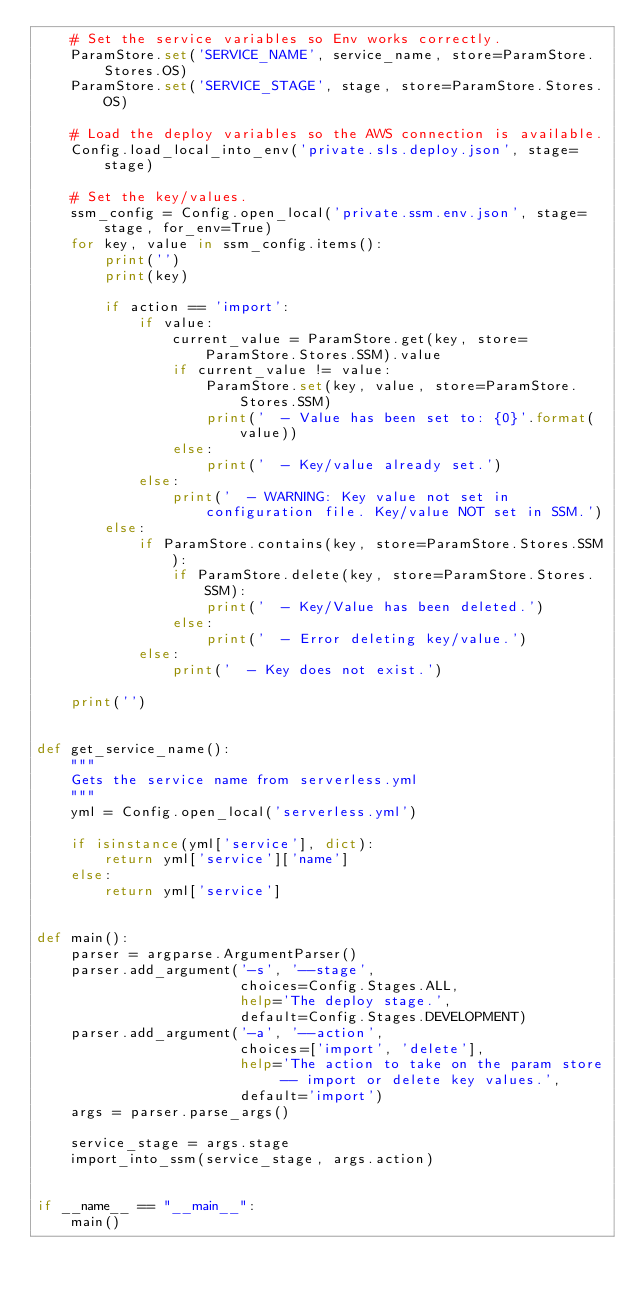<code> <loc_0><loc_0><loc_500><loc_500><_Python_>    # Set the service variables so Env works correctly.
    ParamStore.set('SERVICE_NAME', service_name, store=ParamStore.Stores.OS)
    ParamStore.set('SERVICE_STAGE', stage, store=ParamStore.Stores.OS)

    # Load the deploy variables so the AWS connection is available.
    Config.load_local_into_env('private.sls.deploy.json', stage=stage)

    # Set the key/values.
    ssm_config = Config.open_local('private.ssm.env.json', stage=stage, for_env=True)
    for key, value in ssm_config.items():
        print('')
        print(key)

        if action == 'import':
            if value:
                current_value = ParamStore.get(key, store=ParamStore.Stores.SSM).value
                if current_value != value:
                    ParamStore.set(key, value, store=ParamStore.Stores.SSM)
                    print('  - Value has been set to: {0}'.format(value))
                else:
                    print('  - Key/value already set.')
            else:
                print('  - WARNING: Key value not set in configuration file. Key/value NOT set in SSM.')
        else:
            if ParamStore.contains(key, store=ParamStore.Stores.SSM):
                if ParamStore.delete(key, store=ParamStore.Stores.SSM):
                    print('  - Key/Value has been deleted.')
                else:
                    print('  - Error deleting key/value.')
            else:
                print('  - Key does not exist.')

    print('')


def get_service_name():
    """
    Gets the service name from serverless.yml
    """
    yml = Config.open_local('serverless.yml')

    if isinstance(yml['service'], dict):
        return yml['service']['name']
    else:
        return yml['service']


def main():
    parser = argparse.ArgumentParser()
    parser.add_argument('-s', '--stage',
                        choices=Config.Stages.ALL,
                        help='The deploy stage.',
                        default=Config.Stages.DEVELOPMENT)
    parser.add_argument('-a', '--action',
                        choices=['import', 'delete'],
                        help='The action to take on the param store -- import or delete key values.',
                        default='import')
    args = parser.parse_args()

    service_stage = args.stage
    import_into_ssm(service_stage, args.action)


if __name__ == "__main__":
    main()
</code> 